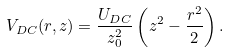Convert formula to latex. <formula><loc_0><loc_0><loc_500><loc_500>V _ { D C } ( r , z ) = \frac { U _ { D C } } { z _ { 0 } ^ { 2 } } \left ( z ^ { 2 } - \frac { r ^ { 2 } } { 2 } \right ) .</formula> 